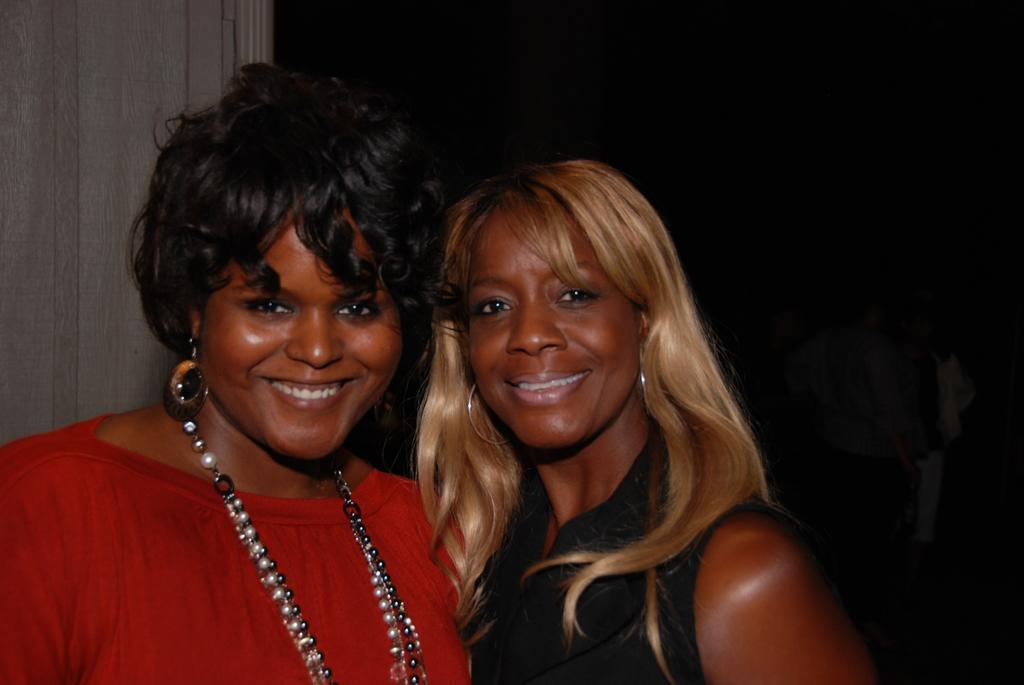How many people are in the image? There are two persons in the image. What expressions do the persons have? Both persons are smiling. Can you describe the background of the image? There are people in the dark background of the image. What type of nail can be seen in the image? There is no nail present in the image. Can you describe the spark coming from the grandmother's hand in the image? There is no grandmother or spark present in the image. 